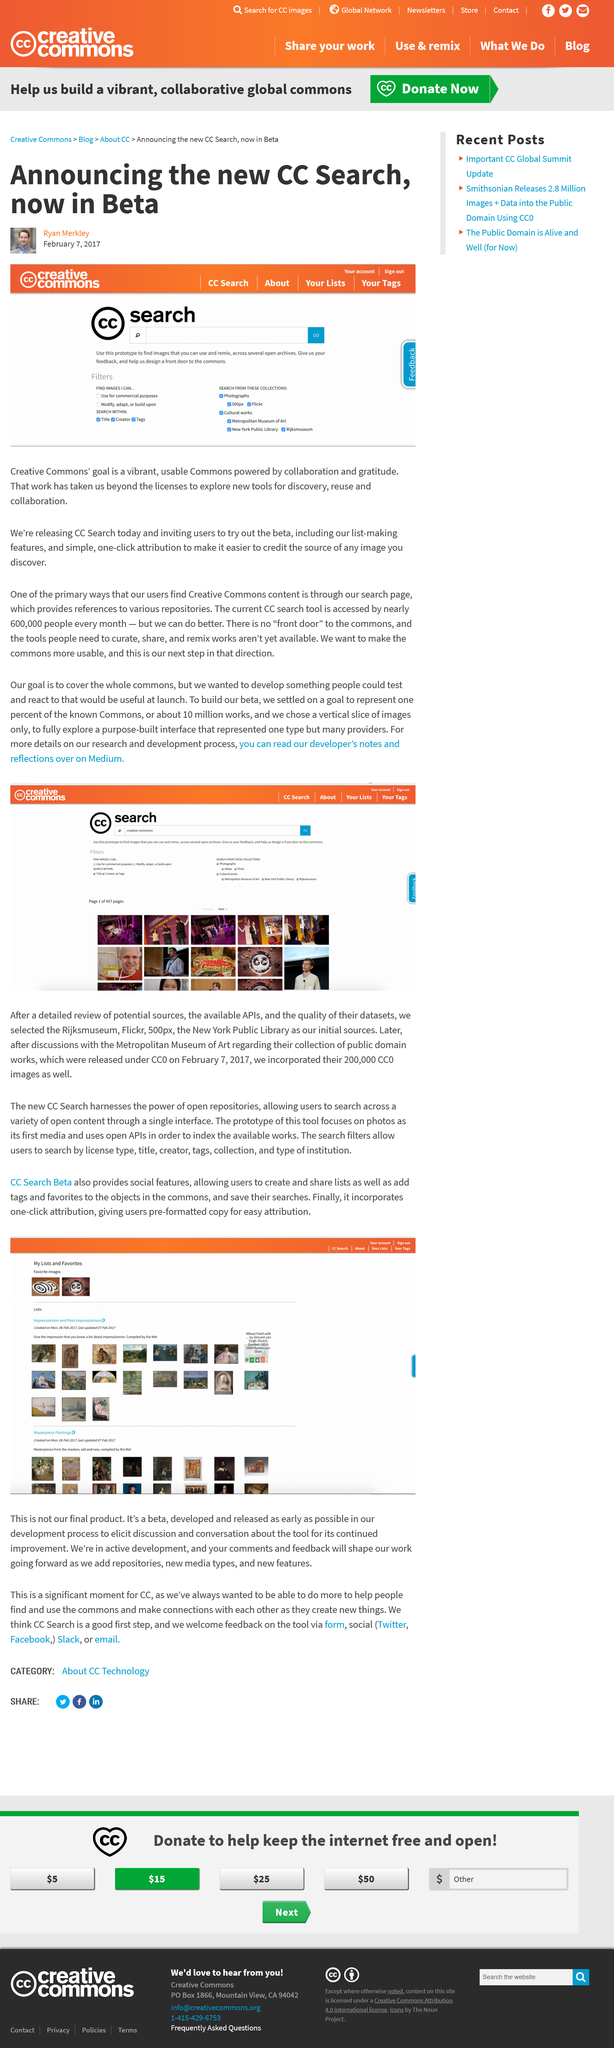List a handful of essential elements in this visual. On February 7th, 2017, the beta of the Creative Commons search was released. The head shot pictured is Ryan Merkley's head shot. On February 7th, 2017, the CC search beta was announced. 